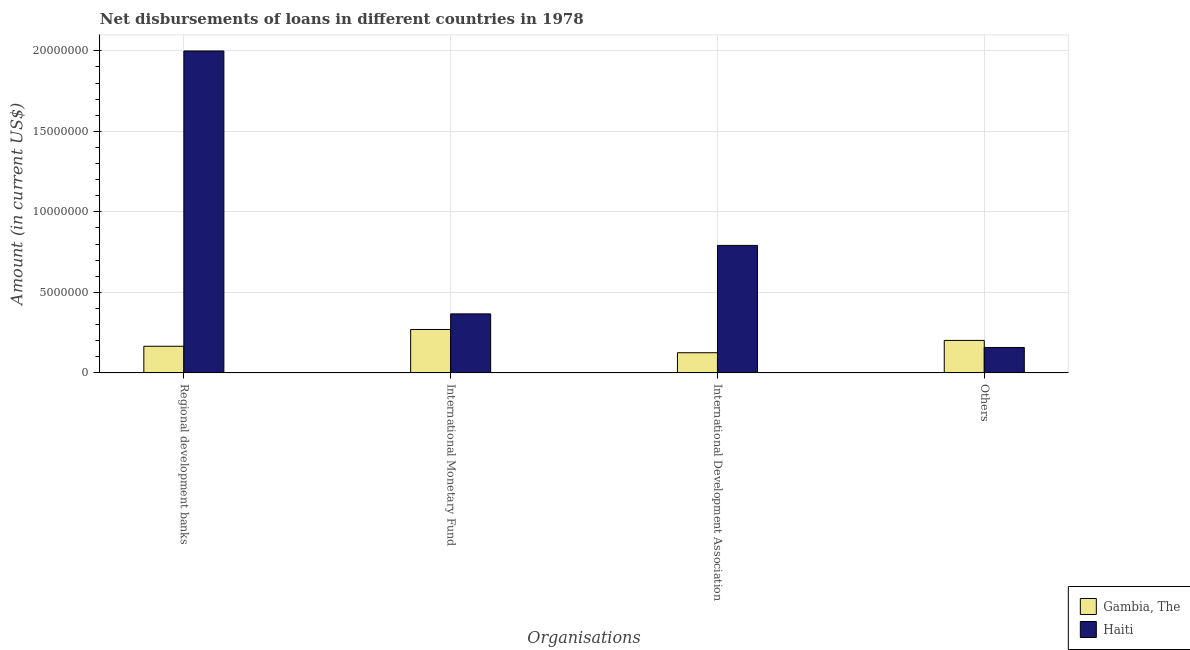How many different coloured bars are there?
Ensure brevity in your answer.  2. How many bars are there on the 1st tick from the left?
Offer a terse response. 2. How many bars are there on the 2nd tick from the right?
Make the answer very short. 2. What is the label of the 2nd group of bars from the left?
Keep it short and to the point. International Monetary Fund. What is the amount of loan disimbursed by international monetary fund in Gambia, The?
Ensure brevity in your answer.  2.70e+06. Across all countries, what is the maximum amount of loan disimbursed by international development association?
Ensure brevity in your answer.  7.92e+06. Across all countries, what is the minimum amount of loan disimbursed by other organisations?
Keep it short and to the point. 1.58e+06. In which country was the amount of loan disimbursed by regional development banks maximum?
Provide a short and direct response. Haiti. In which country was the amount of loan disimbursed by international monetary fund minimum?
Provide a succinct answer. Gambia, The. What is the total amount of loan disimbursed by regional development banks in the graph?
Offer a terse response. 2.16e+07. What is the difference between the amount of loan disimbursed by international monetary fund in Gambia, The and that in Haiti?
Provide a succinct answer. -9.68e+05. What is the difference between the amount of loan disimbursed by international monetary fund in Gambia, The and the amount of loan disimbursed by international development association in Haiti?
Ensure brevity in your answer.  -5.22e+06. What is the average amount of loan disimbursed by international monetary fund per country?
Provide a short and direct response. 3.18e+06. What is the difference between the amount of loan disimbursed by other organisations and amount of loan disimbursed by international development association in Gambia, The?
Provide a short and direct response. 7.64e+05. In how many countries, is the amount of loan disimbursed by other organisations greater than 9000000 US$?
Your answer should be compact. 0. What is the ratio of the amount of loan disimbursed by other organisations in Haiti to that in Gambia, The?
Provide a short and direct response. 0.78. Is the difference between the amount of loan disimbursed by regional development banks in Gambia, The and Haiti greater than the difference between the amount of loan disimbursed by other organisations in Gambia, The and Haiti?
Give a very brief answer. No. What is the difference between the highest and the second highest amount of loan disimbursed by international monetary fund?
Your answer should be compact. 9.68e+05. What is the difference between the highest and the lowest amount of loan disimbursed by international development association?
Provide a short and direct response. 6.66e+06. In how many countries, is the amount of loan disimbursed by international development association greater than the average amount of loan disimbursed by international development association taken over all countries?
Provide a succinct answer. 1. Is the sum of the amount of loan disimbursed by international monetary fund in Gambia, The and Haiti greater than the maximum amount of loan disimbursed by other organisations across all countries?
Your response must be concise. Yes. What does the 1st bar from the left in International Monetary Fund represents?
Give a very brief answer. Gambia, The. What does the 1st bar from the right in International Monetary Fund represents?
Your answer should be very brief. Haiti. How many bars are there?
Your answer should be very brief. 8. Are all the bars in the graph horizontal?
Provide a short and direct response. No. How many countries are there in the graph?
Provide a succinct answer. 2. Are the values on the major ticks of Y-axis written in scientific E-notation?
Provide a short and direct response. No. Does the graph contain any zero values?
Offer a very short reply. No. Where does the legend appear in the graph?
Offer a terse response. Bottom right. How are the legend labels stacked?
Keep it short and to the point. Vertical. What is the title of the graph?
Give a very brief answer. Net disbursements of loans in different countries in 1978. Does "Portugal" appear as one of the legend labels in the graph?
Your answer should be compact. No. What is the label or title of the X-axis?
Offer a very short reply. Organisations. What is the Amount (in current US$) of Gambia, The in Regional development banks?
Your response must be concise. 1.65e+06. What is the Amount (in current US$) in Haiti in Regional development banks?
Ensure brevity in your answer.  2.00e+07. What is the Amount (in current US$) of Gambia, The in International Monetary Fund?
Provide a short and direct response. 2.70e+06. What is the Amount (in current US$) in Haiti in International Monetary Fund?
Keep it short and to the point. 3.66e+06. What is the Amount (in current US$) of Gambia, The in International Development Association?
Make the answer very short. 1.25e+06. What is the Amount (in current US$) of Haiti in International Development Association?
Keep it short and to the point. 7.92e+06. What is the Amount (in current US$) in Gambia, The in Others?
Your answer should be very brief. 2.02e+06. What is the Amount (in current US$) of Haiti in Others?
Give a very brief answer. 1.58e+06. Across all Organisations, what is the maximum Amount (in current US$) in Gambia, The?
Offer a very short reply. 2.70e+06. Across all Organisations, what is the maximum Amount (in current US$) in Haiti?
Give a very brief answer. 2.00e+07. Across all Organisations, what is the minimum Amount (in current US$) in Gambia, The?
Your answer should be very brief. 1.25e+06. Across all Organisations, what is the minimum Amount (in current US$) in Haiti?
Your response must be concise. 1.58e+06. What is the total Amount (in current US$) in Gambia, The in the graph?
Your answer should be compact. 7.61e+06. What is the total Amount (in current US$) of Haiti in the graph?
Your response must be concise. 3.31e+07. What is the difference between the Amount (in current US$) of Gambia, The in Regional development banks and that in International Monetary Fund?
Offer a terse response. -1.04e+06. What is the difference between the Amount (in current US$) in Haiti in Regional development banks and that in International Monetary Fund?
Keep it short and to the point. 1.63e+07. What is the difference between the Amount (in current US$) of Gambia, The in Regional development banks and that in International Development Association?
Ensure brevity in your answer.  4.01e+05. What is the difference between the Amount (in current US$) in Haiti in Regional development banks and that in International Development Association?
Give a very brief answer. 1.21e+07. What is the difference between the Amount (in current US$) in Gambia, The in Regional development banks and that in Others?
Your response must be concise. -3.63e+05. What is the difference between the Amount (in current US$) of Haiti in Regional development banks and that in Others?
Your response must be concise. 1.84e+07. What is the difference between the Amount (in current US$) of Gambia, The in International Monetary Fund and that in International Development Association?
Provide a succinct answer. 1.44e+06. What is the difference between the Amount (in current US$) of Haiti in International Monetary Fund and that in International Development Association?
Your response must be concise. -4.25e+06. What is the difference between the Amount (in current US$) in Gambia, The in International Monetary Fund and that in Others?
Your answer should be compact. 6.80e+05. What is the difference between the Amount (in current US$) in Haiti in International Monetary Fund and that in Others?
Your answer should be very brief. 2.09e+06. What is the difference between the Amount (in current US$) in Gambia, The in International Development Association and that in Others?
Ensure brevity in your answer.  -7.64e+05. What is the difference between the Amount (in current US$) of Haiti in International Development Association and that in Others?
Ensure brevity in your answer.  6.34e+06. What is the difference between the Amount (in current US$) in Gambia, The in Regional development banks and the Amount (in current US$) in Haiti in International Monetary Fund?
Your response must be concise. -2.01e+06. What is the difference between the Amount (in current US$) in Gambia, The in Regional development banks and the Amount (in current US$) in Haiti in International Development Association?
Provide a succinct answer. -6.26e+06. What is the difference between the Amount (in current US$) in Gambia, The in Regional development banks and the Amount (in current US$) in Haiti in Others?
Give a very brief answer. 7.70e+04. What is the difference between the Amount (in current US$) in Gambia, The in International Monetary Fund and the Amount (in current US$) in Haiti in International Development Association?
Provide a succinct answer. -5.22e+06. What is the difference between the Amount (in current US$) of Gambia, The in International Monetary Fund and the Amount (in current US$) of Haiti in Others?
Offer a very short reply. 1.12e+06. What is the difference between the Amount (in current US$) in Gambia, The in International Development Association and the Amount (in current US$) in Haiti in Others?
Your answer should be compact. -3.24e+05. What is the average Amount (in current US$) in Gambia, The per Organisations?
Your response must be concise. 1.90e+06. What is the average Amount (in current US$) in Haiti per Organisations?
Give a very brief answer. 8.29e+06. What is the difference between the Amount (in current US$) of Gambia, The and Amount (in current US$) of Haiti in Regional development banks?
Give a very brief answer. -1.83e+07. What is the difference between the Amount (in current US$) of Gambia, The and Amount (in current US$) of Haiti in International Monetary Fund?
Your response must be concise. -9.68e+05. What is the difference between the Amount (in current US$) in Gambia, The and Amount (in current US$) in Haiti in International Development Association?
Provide a short and direct response. -6.66e+06. What is the ratio of the Amount (in current US$) in Gambia, The in Regional development banks to that in International Monetary Fund?
Provide a short and direct response. 0.61. What is the ratio of the Amount (in current US$) in Haiti in Regional development banks to that in International Monetary Fund?
Provide a short and direct response. 5.46. What is the ratio of the Amount (in current US$) in Gambia, The in Regional development banks to that in International Development Association?
Keep it short and to the point. 1.32. What is the ratio of the Amount (in current US$) in Haiti in Regional development banks to that in International Development Association?
Your answer should be very brief. 2.53. What is the ratio of the Amount (in current US$) in Gambia, The in Regional development banks to that in Others?
Your response must be concise. 0.82. What is the ratio of the Amount (in current US$) of Haiti in Regional development banks to that in Others?
Ensure brevity in your answer.  12.69. What is the ratio of the Amount (in current US$) in Gambia, The in International Monetary Fund to that in International Development Association?
Your answer should be very brief. 2.15. What is the ratio of the Amount (in current US$) in Haiti in International Monetary Fund to that in International Development Association?
Offer a very short reply. 0.46. What is the ratio of the Amount (in current US$) in Gambia, The in International Monetary Fund to that in Others?
Your answer should be compact. 1.34. What is the ratio of the Amount (in current US$) in Haiti in International Monetary Fund to that in Others?
Provide a succinct answer. 2.33. What is the ratio of the Amount (in current US$) in Gambia, The in International Development Association to that in Others?
Your answer should be compact. 0.62. What is the ratio of the Amount (in current US$) of Haiti in International Development Association to that in Others?
Make the answer very short. 5.03. What is the difference between the highest and the second highest Amount (in current US$) in Gambia, The?
Offer a terse response. 6.80e+05. What is the difference between the highest and the second highest Amount (in current US$) of Haiti?
Offer a very short reply. 1.21e+07. What is the difference between the highest and the lowest Amount (in current US$) of Gambia, The?
Ensure brevity in your answer.  1.44e+06. What is the difference between the highest and the lowest Amount (in current US$) in Haiti?
Ensure brevity in your answer.  1.84e+07. 